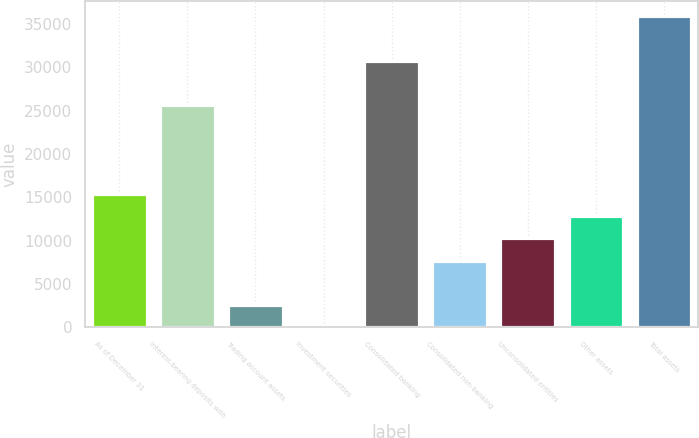Convert chart to OTSL. <chart><loc_0><loc_0><loc_500><loc_500><bar_chart><fcel>As of December 31<fcel>Interest-bearing deposits with<fcel>Trading account assets<fcel>Investment securities<fcel>Consolidated banking<fcel>Consolidated non-banking<fcel>Unconsolidated entities<fcel>Other assets<fcel>Total assets<nl><fcel>15387.6<fcel>25630<fcel>2584.6<fcel>24<fcel>30751.2<fcel>7705.8<fcel>10266.4<fcel>12827<fcel>35872.4<nl></chart> 